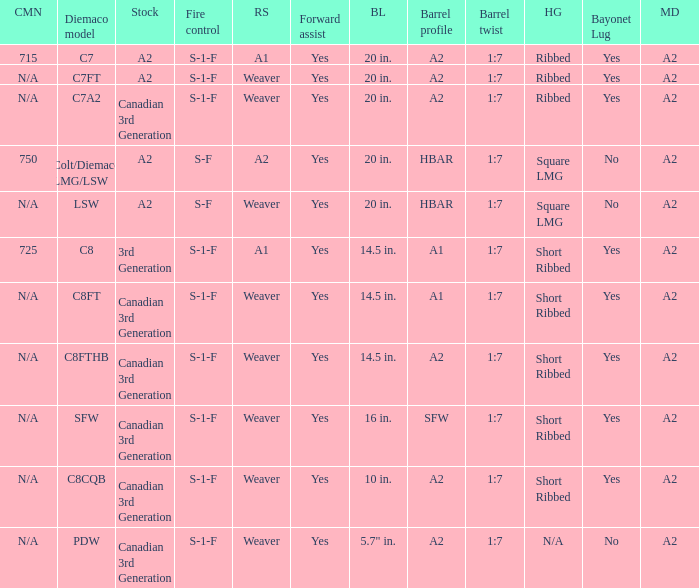Which Barrel twist has a Stock of canadian 3rd generation and a Hand guards of short ribbed? 1:7, 1:7, 1:7, 1:7. 